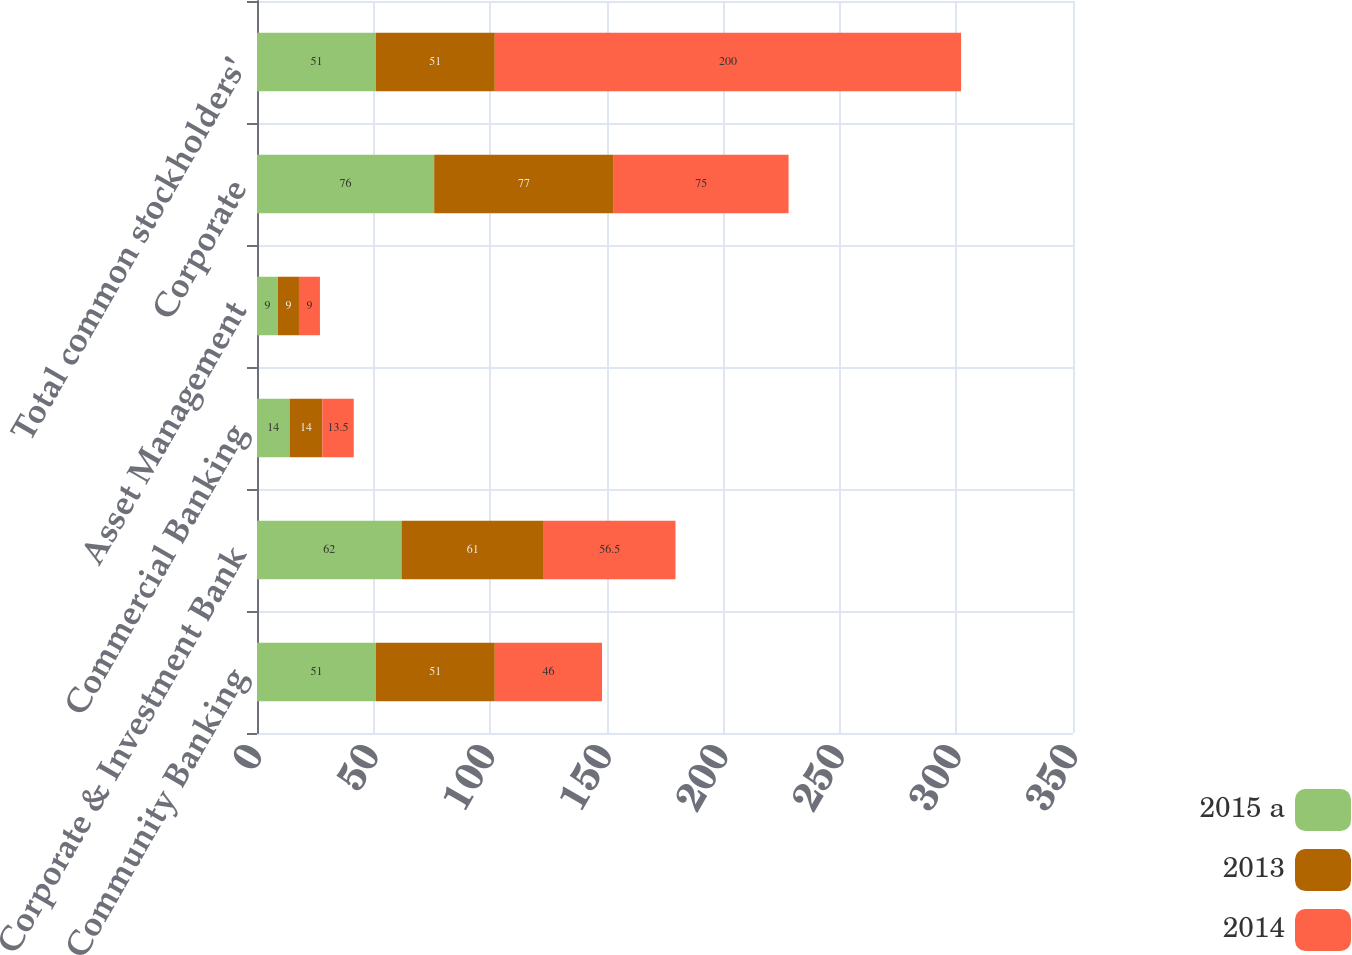Convert chart to OTSL. <chart><loc_0><loc_0><loc_500><loc_500><stacked_bar_chart><ecel><fcel>Consumer & Community Banking<fcel>Corporate & Investment Bank<fcel>Commercial Banking<fcel>Asset Management<fcel>Corporate<fcel>Total common stockholders'<nl><fcel>2015 a<fcel>51<fcel>62<fcel>14<fcel>9<fcel>76<fcel>51<nl><fcel>2013<fcel>51<fcel>61<fcel>14<fcel>9<fcel>77<fcel>51<nl><fcel>2014<fcel>46<fcel>56.5<fcel>13.5<fcel>9<fcel>75<fcel>200<nl></chart> 